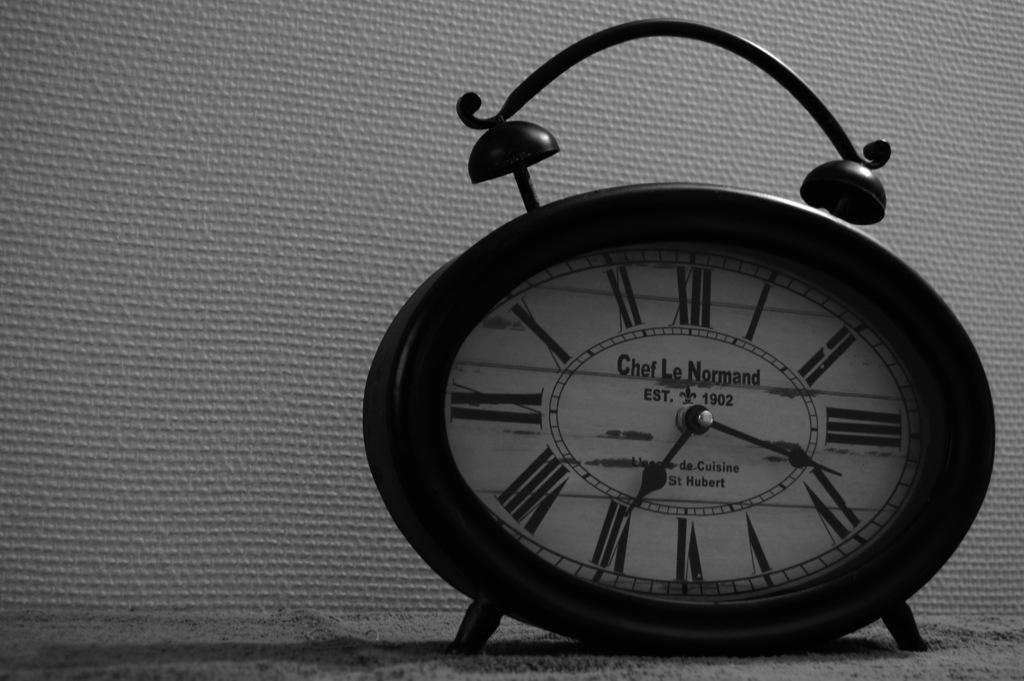What time is shown?
Offer a very short reply. 7:17. What year was the brand established?
Keep it short and to the point. 1902. 